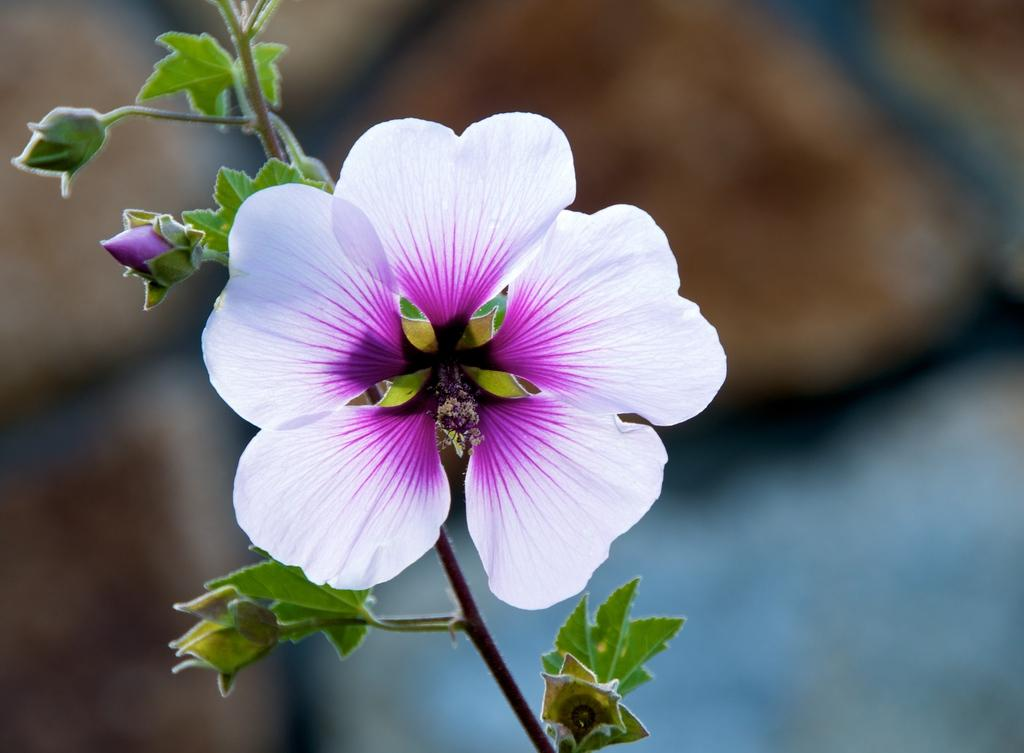What is present in the picture? There is a plant in the picture. What feature of the plant is mentioned? The plant has a flower. How is the flower described? The flower has a white and pink combination, and it has pink buds. Where is the mother sitting with the monkey in the picture? There is no mother or monkey present in the image; it only features a plant with a flower. 